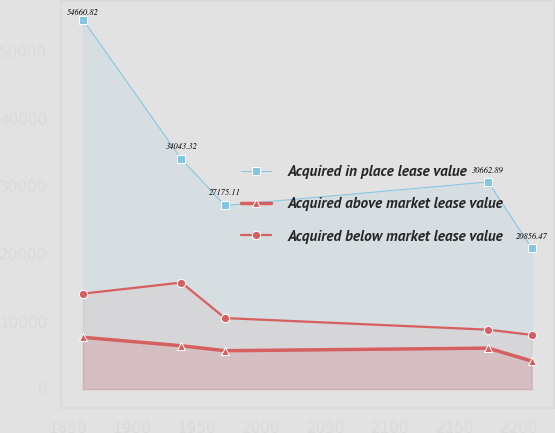Convert chart to OTSL. <chart><loc_0><loc_0><loc_500><loc_500><line_chart><ecel><fcel>Acquired in place lease value<fcel>Acquired above market lease value<fcel>Acquired below market lease value<nl><fcel>1861.96<fcel>54660.8<fcel>7661.6<fcel>14126.8<nl><fcel>1938.19<fcel>34043.3<fcel>6409.33<fcel>15762.3<nl><fcel>1971.92<fcel>27175.1<fcel>5676.08<fcel>10507.8<nl><fcel>2175.64<fcel>30662.9<fcel>6058.58<fcel>8790.61<nl><fcel>2209.37<fcel>20856.5<fcel>4154.09<fcel>8015.98<nl></chart> 